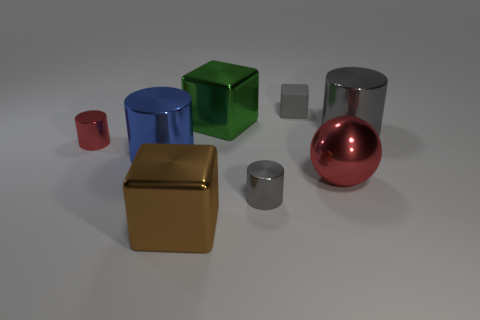Can you describe the colors and shapes of the objects in this image? Certainly! In the image, there are various three-dimensional objects with distinct colors and shapes. From left to right, we have: a small red cylinder, a medium-sized blue cylinder, a large green cube, a small grey cube, a small semi-transparent grey block, a medium gold-colored cube, a small silver cylinder, and a large red sphere. The colors are vivid, and the shapes include cylinders, cubes, spheres, and a rectangular block. 